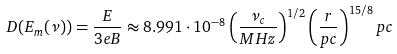Convert formula to latex. <formula><loc_0><loc_0><loc_500><loc_500>D ( E _ { m } ( \nu ) ) = \frac { E } { 3 e B } \approx 8 . 9 9 1 \cdot 1 0 ^ { - 8 } \left ( \frac { \nu _ { c } } { M H z } \right ) ^ { 1 / 2 } \left ( \frac { r } { p c } \right ) ^ { 1 5 / 8 } p c</formula> 